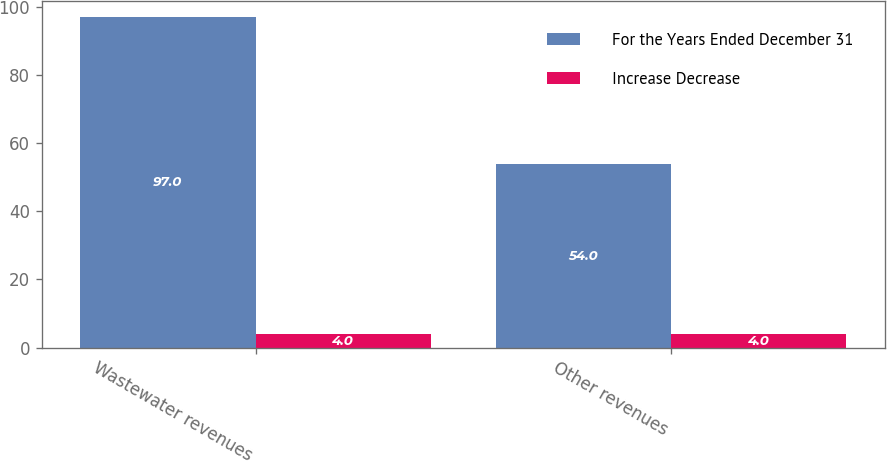Convert chart. <chart><loc_0><loc_0><loc_500><loc_500><stacked_bar_chart><ecel><fcel>Wastewater revenues<fcel>Other revenues<nl><fcel>For the Years Ended December 31<fcel>97<fcel>54<nl><fcel>Increase Decrease<fcel>4<fcel>4<nl></chart> 